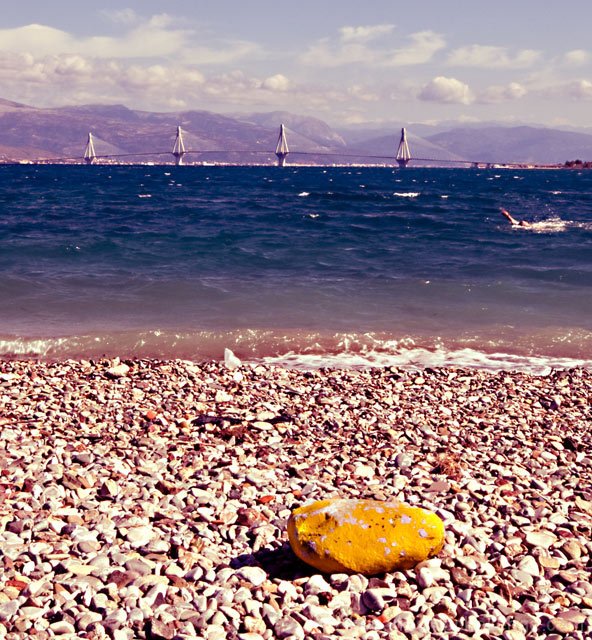Is the overall clarity of the image acceptable?
A. Yes
B. No
Answer with the option's letter from the given choices directly.
 A. 